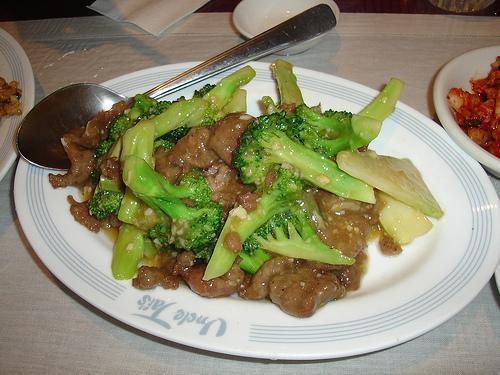How many utensils are visible?
Give a very brief answer. 1. 